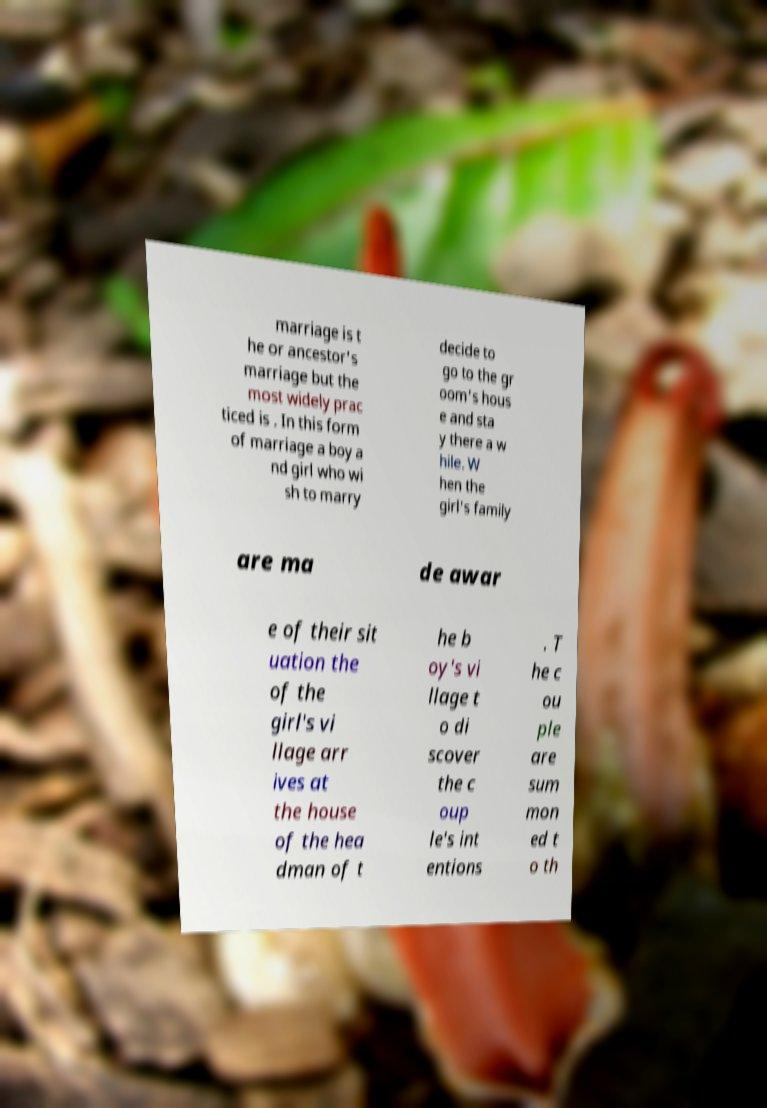Can you read and provide the text displayed in the image?This photo seems to have some interesting text. Can you extract and type it out for me? marriage is t he or ancestor's marriage but the most widely prac ticed is . In this form of marriage a boy a nd girl who wi sh to marry decide to go to the gr oom's hous e and sta y there a w hile. W hen the girl's family are ma de awar e of their sit uation the of the girl's vi llage arr ives at the house of the hea dman of t he b oy's vi llage t o di scover the c oup le's int entions . T he c ou ple are sum mon ed t o th 